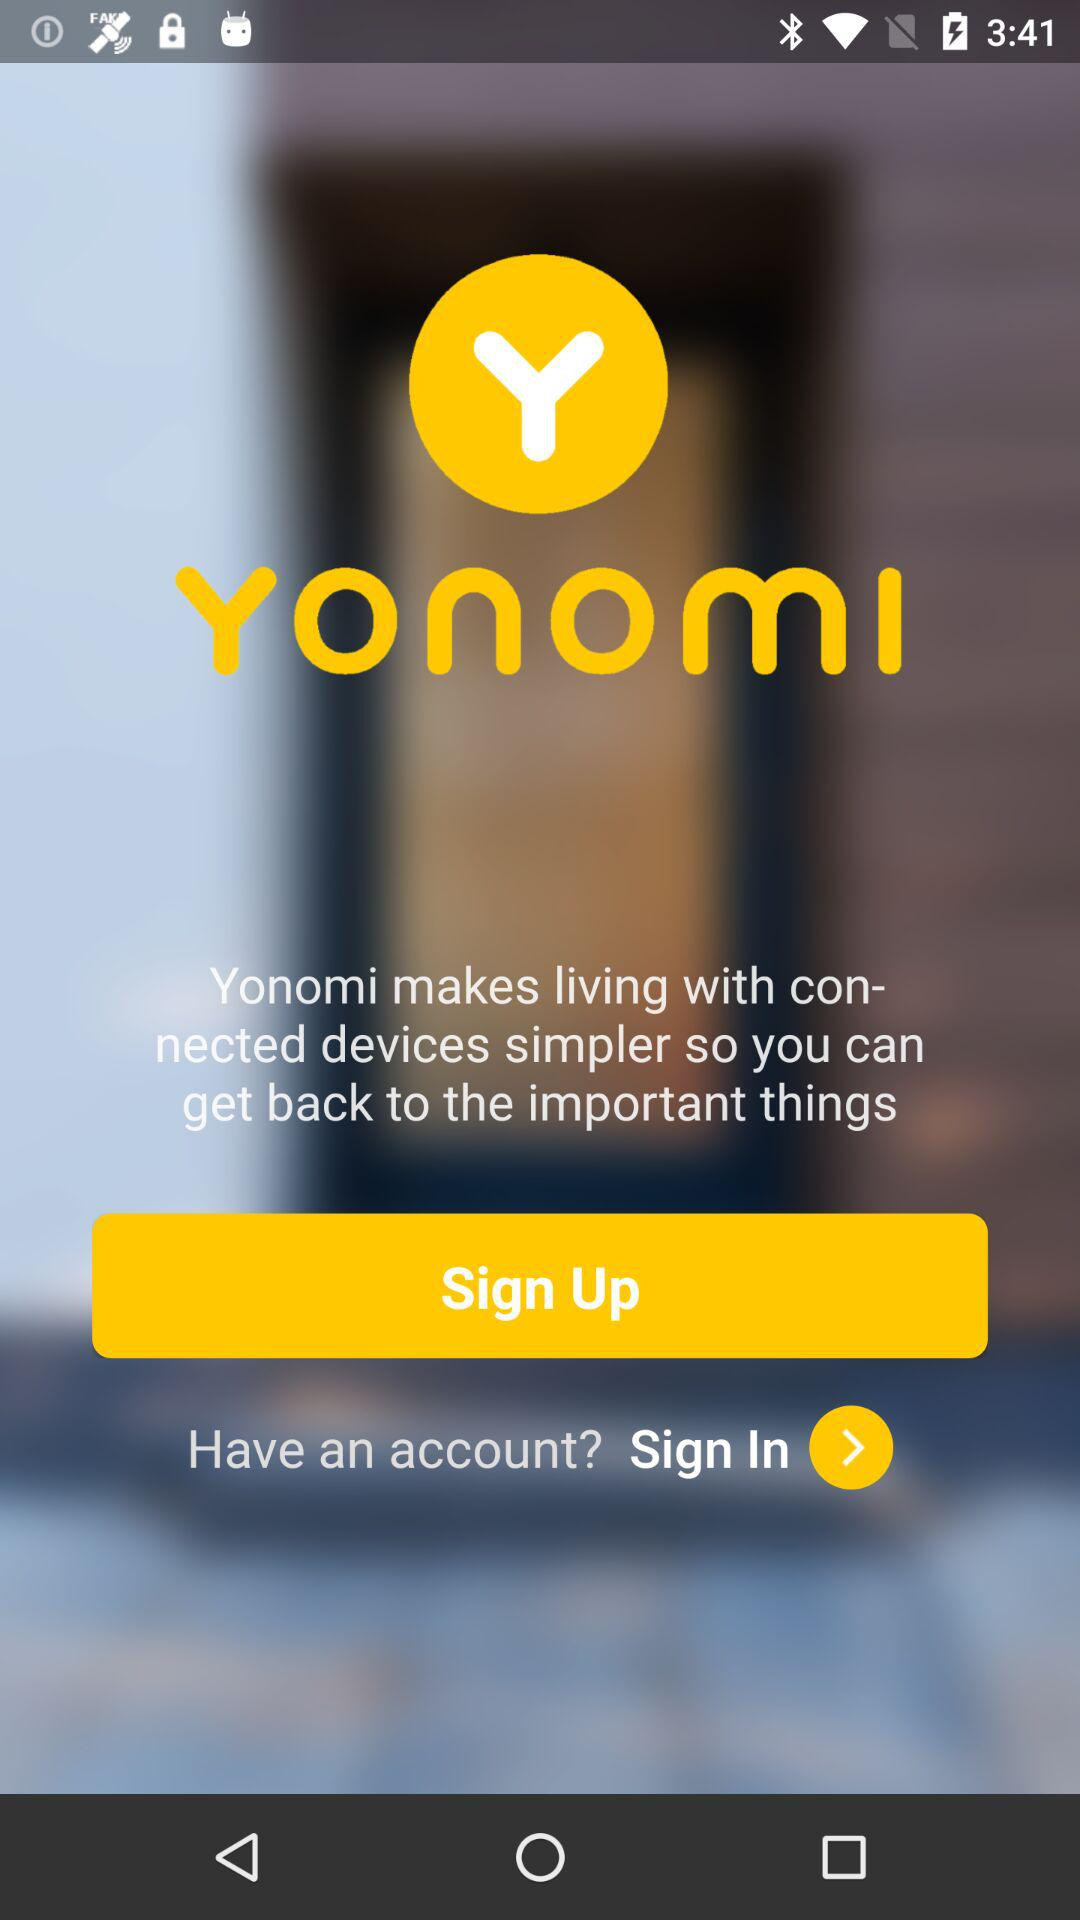What is the app name? The app name is "Yonomi". 